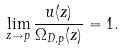<formula> <loc_0><loc_0><loc_500><loc_500>\lim _ { z \to p } \frac { u ( z ) } { \Omega _ { D , p } ( z ) } = 1 .</formula> 